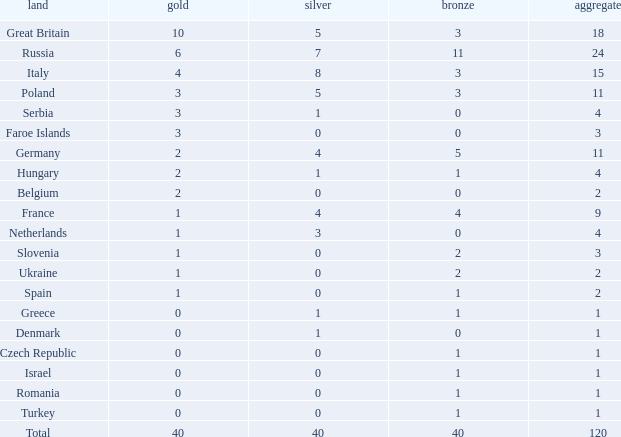What is the average Gold entry for the Netherlands that also has a Bronze entry that is greater than 0? None. 